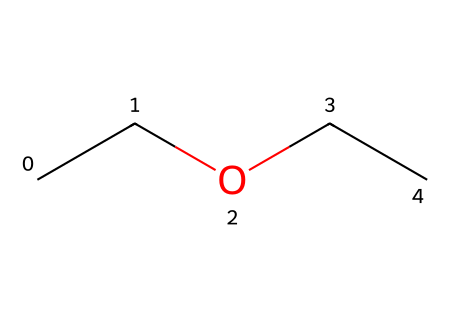What is the molecular formula of diethyl ether? The SMILES representation "CCOCC" indicates two ethyl groups (C2H5) and one ether oxygen (O) in between. Thus, the molecular formula can be calculated as C4H10O.
Answer: C4H10O How many carbon atoms are in diethyl ether? The SMILES "CCOCC" shows two "C" pairs, each representing an ethyl group. In total, there are four carbon atoms represented.
Answer: 4 What type of compound is diethyl ether? Diethyl ether contains an oxygen atom connecting two alkyl (ethyl) groups. This structure classifies it as an ether.
Answer: ether What is the functional group present in diethyl ether? The structure "CCOCC" includes an oxygen atom between the two carbon chains, which indicates that the functional group of the compound is an ether (-O-).
Answer: ether What is the total number of hydrogen atoms in diethyl ether? Each ethyl group contributes five hydrogen atoms (C2H5), and since there are two ethyl groups, the total number of hydrogen atoms is 10 (5 + 5).
Answer: 10 Why is diethyl ether used as an anesthetic in sports medicine? Due to its chemical structure that allows rapid sedation and its relatively low boiling point, diethyl ether can easily vaporize for inhalation, making it a suitable anesthetic.
Answer: rapid sedation 